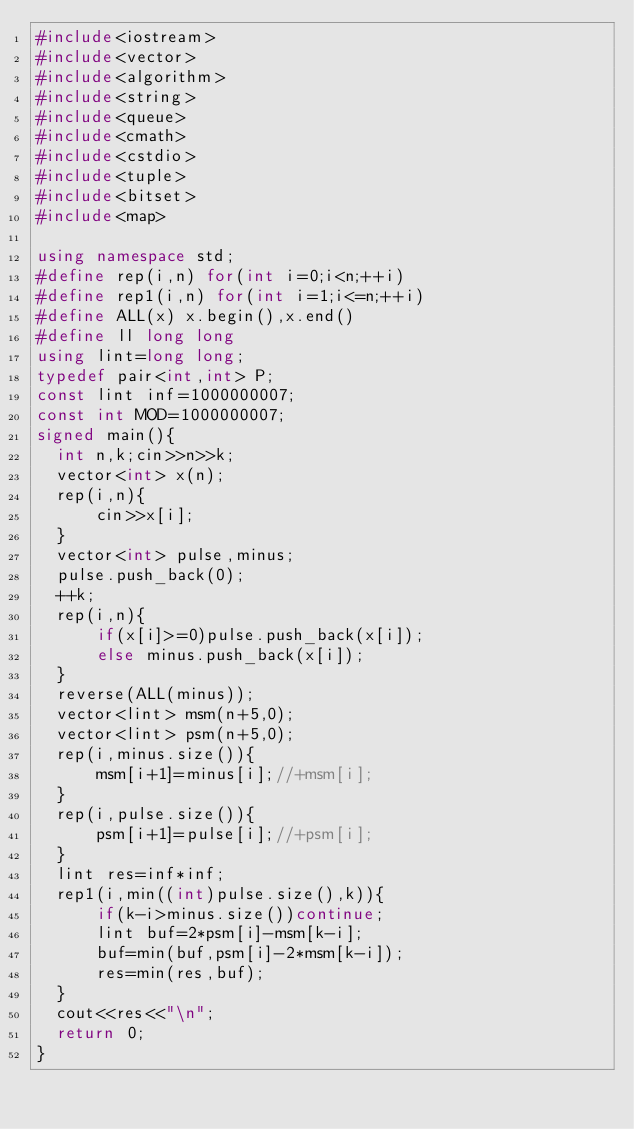<code> <loc_0><loc_0><loc_500><loc_500><_C++_>#include<iostream>
#include<vector>
#include<algorithm>
#include<string>
#include<queue>
#include<cmath>
#include<cstdio>
#include<tuple>
#include<bitset>
#include<map>

using namespace std;
#define rep(i,n) for(int i=0;i<n;++i)
#define rep1(i,n) for(int i=1;i<=n;++i)
#define ALL(x) x.begin(),x.end()
#define ll long long
using lint=long long;
typedef pair<int,int> P;
const lint inf=1000000007;
const int MOD=1000000007;
signed main(){
  int n,k;cin>>n>>k;
  vector<int> x(n);
  rep(i,n){
      cin>>x[i];
  }
  vector<int> pulse,minus;
  pulse.push_back(0);
  ++k;
  rep(i,n){
      if(x[i]>=0)pulse.push_back(x[i]);
      else minus.push_back(x[i]);
  }
  reverse(ALL(minus));
  vector<lint> msm(n+5,0);
  vector<lint> psm(n+5,0);
  rep(i,minus.size()){
      msm[i+1]=minus[i];//+msm[i];
  }
  rep(i,pulse.size()){
      psm[i+1]=pulse[i];//+psm[i];
  }
  lint res=inf*inf;
  rep1(i,min((int)pulse.size(),k)){
      if(k-i>minus.size())continue;
      lint buf=2*psm[i]-msm[k-i];
      buf=min(buf,psm[i]-2*msm[k-i]);
      res=min(res,buf);
  }
  cout<<res<<"\n";
  return 0;
}</code> 